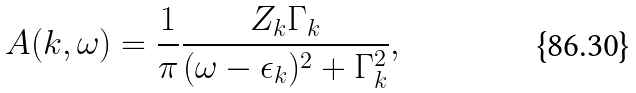Convert formula to latex. <formula><loc_0><loc_0><loc_500><loc_500>A ( { k } , \omega ) = \frac { 1 } { \pi } \frac { Z _ { k } \Gamma _ { k } } { ( \omega - \epsilon _ { k } ) ^ { 2 } + \Gamma ^ { 2 } _ { k } } ,</formula> 